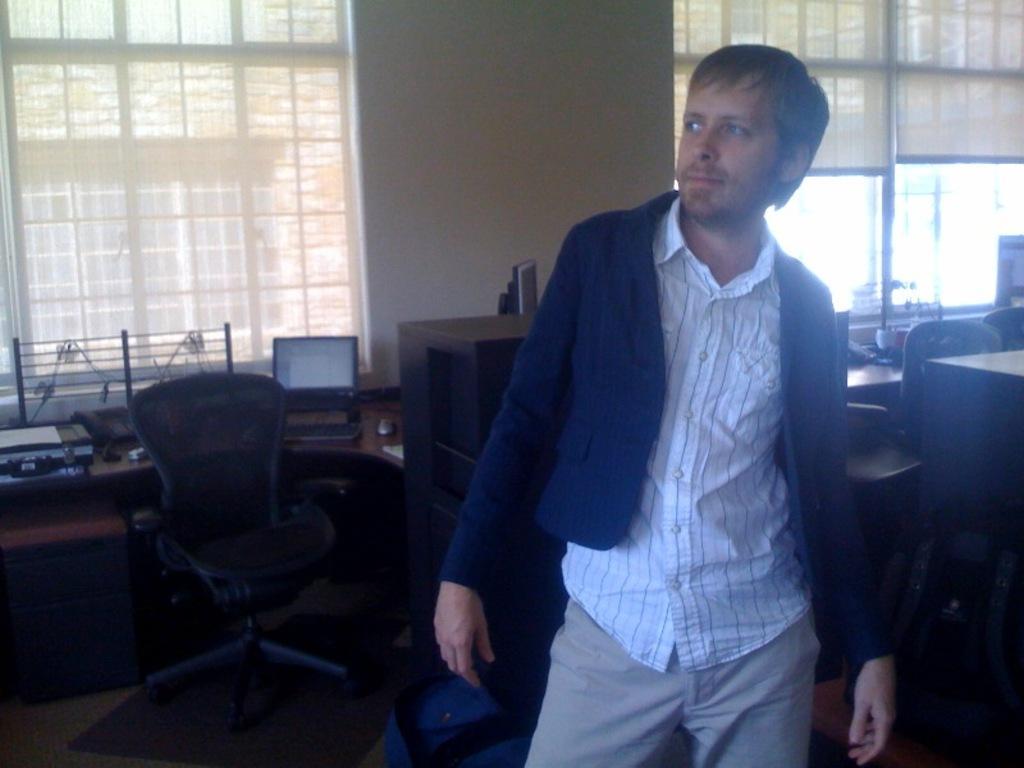Please provide a concise description of this image. In this image i can see a person standing. In the background i can see few chairs,a laptop, the wall, windows and the window blind. 